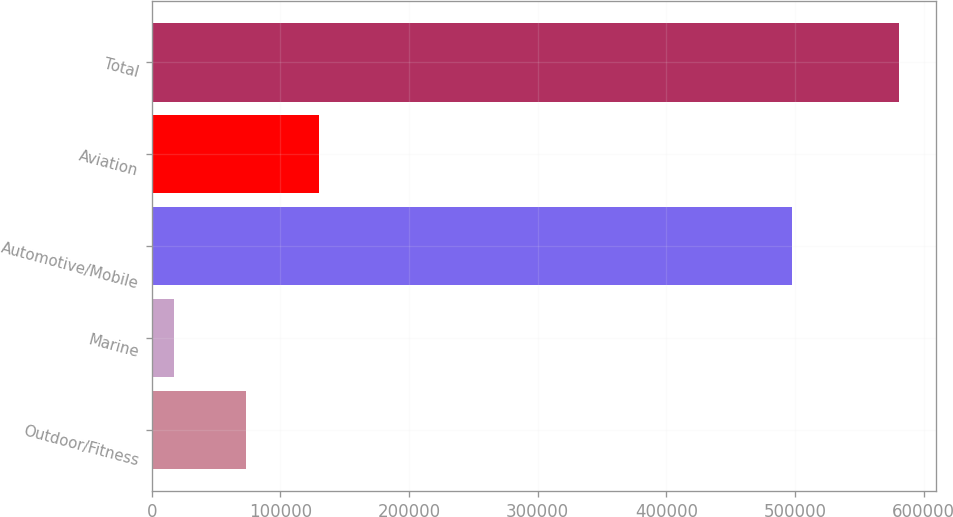Convert chart to OTSL. <chart><loc_0><loc_0><loc_500><loc_500><bar_chart><fcel>Outdoor/Fitness<fcel>Marine<fcel>Automotive/Mobile<fcel>Aviation<fcel>Total<nl><fcel>73582.2<fcel>17217<fcel>498014<fcel>129947<fcel>580869<nl></chart> 